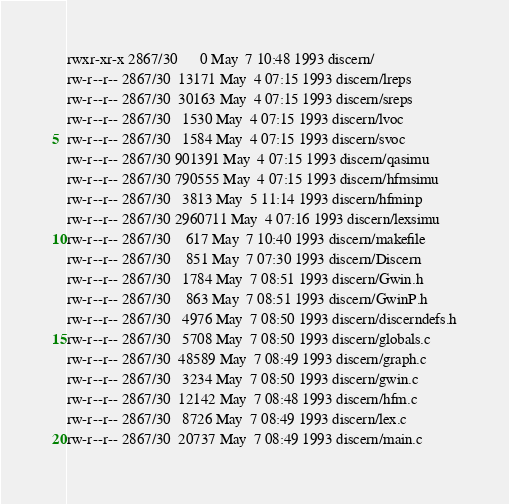<code> <loc_0><loc_0><loc_500><loc_500><_HTML_>rwxr-xr-x 2867/30      0 May  7 10:48 1993 discern/
rw-r--r-- 2867/30  13171 May  4 07:15 1993 discern/lreps
rw-r--r-- 2867/30  30163 May  4 07:15 1993 discern/sreps
rw-r--r-- 2867/30   1530 May  4 07:15 1993 discern/lvoc
rw-r--r-- 2867/30   1584 May  4 07:15 1993 discern/svoc
rw-r--r-- 2867/30 901391 May  4 07:15 1993 discern/qasimu
rw-r--r-- 2867/30 790555 May  4 07:15 1993 discern/hfmsimu
rw-r--r-- 2867/30   3813 May  5 11:14 1993 discern/hfminp
rw-r--r-- 2867/30 2960711 May  4 07:16 1993 discern/lexsimu
rw-r--r-- 2867/30    617 May  7 10:40 1993 discern/makefile
rw-r--r-- 2867/30    851 May  7 07:30 1993 discern/Discern
rw-r--r-- 2867/30   1784 May  7 08:51 1993 discern/Gwin.h
rw-r--r-- 2867/30    863 May  7 08:51 1993 discern/GwinP.h
rw-r--r-- 2867/30   4976 May  7 08:50 1993 discern/discerndefs.h
rw-r--r-- 2867/30   5708 May  7 08:50 1993 discern/globals.c
rw-r--r-- 2867/30  48589 May  7 08:49 1993 discern/graph.c
rw-r--r-- 2867/30   3234 May  7 08:50 1993 discern/gwin.c
rw-r--r-- 2867/30  12142 May  7 08:48 1993 discern/hfm.c
rw-r--r-- 2867/30   8726 May  7 08:49 1993 discern/lex.c
rw-r--r-- 2867/30  20737 May  7 08:49 1993 discern/main.c</code> 